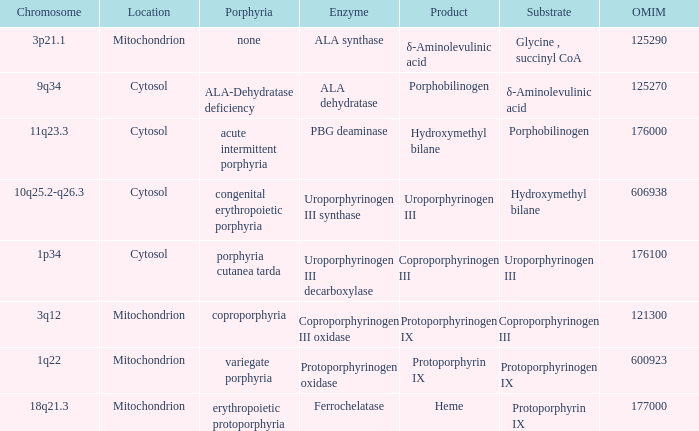What is protoporphyrin ix's substrate? Protoporphyrinogen IX. 